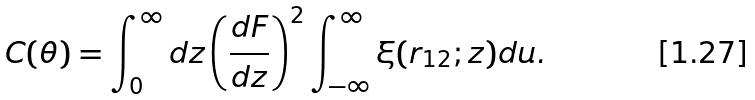<formula> <loc_0><loc_0><loc_500><loc_500>C ( \theta ) = \int _ { 0 } ^ { \infty } d z \left ( \frac { d F } { d z } \right ) ^ { 2 } \int _ { - \infty } ^ { \infty } \xi ( r _ { 1 2 } ; z ) d u .</formula> 